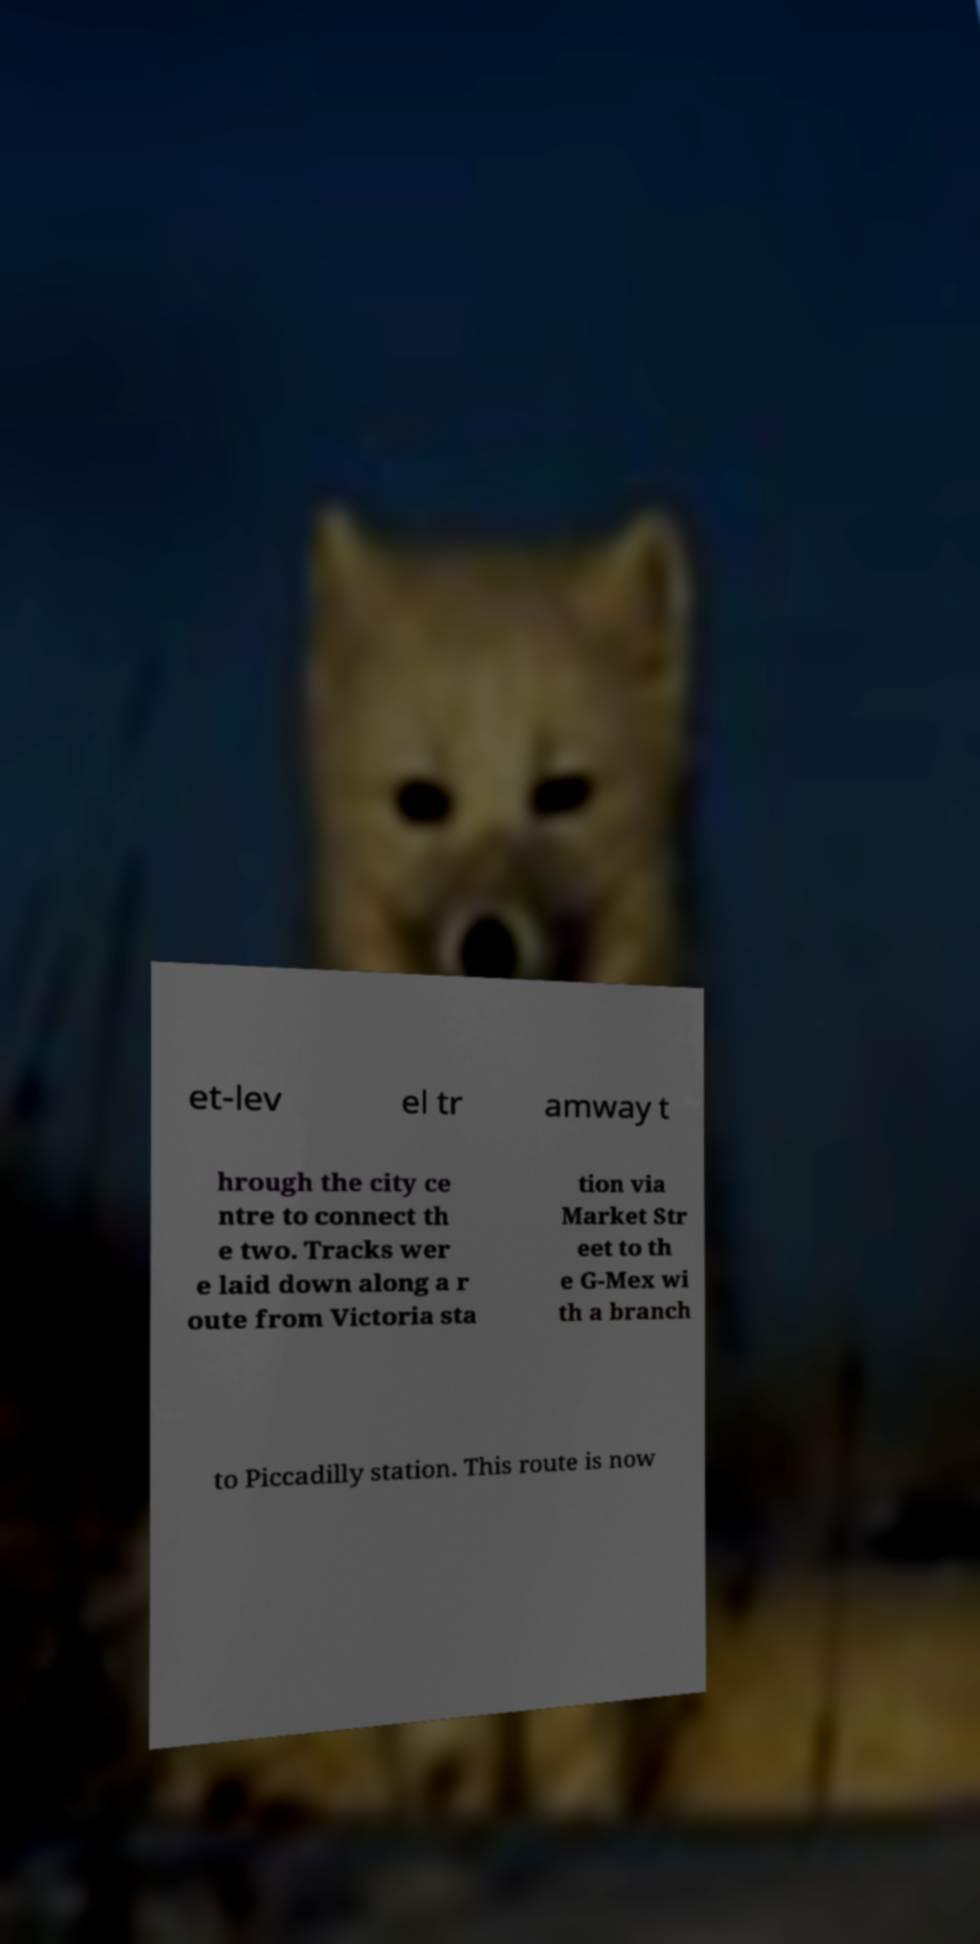I need the written content from this picture converted into text. Can you do that? et-lev el tr amway t hrough the city ce ntre to connect th e two. Tracks wer e laid down along a r oute from Victoria sta tion via Market Str eet to th e G-Mex wi th a branch to Piccadilly station. This route is now 